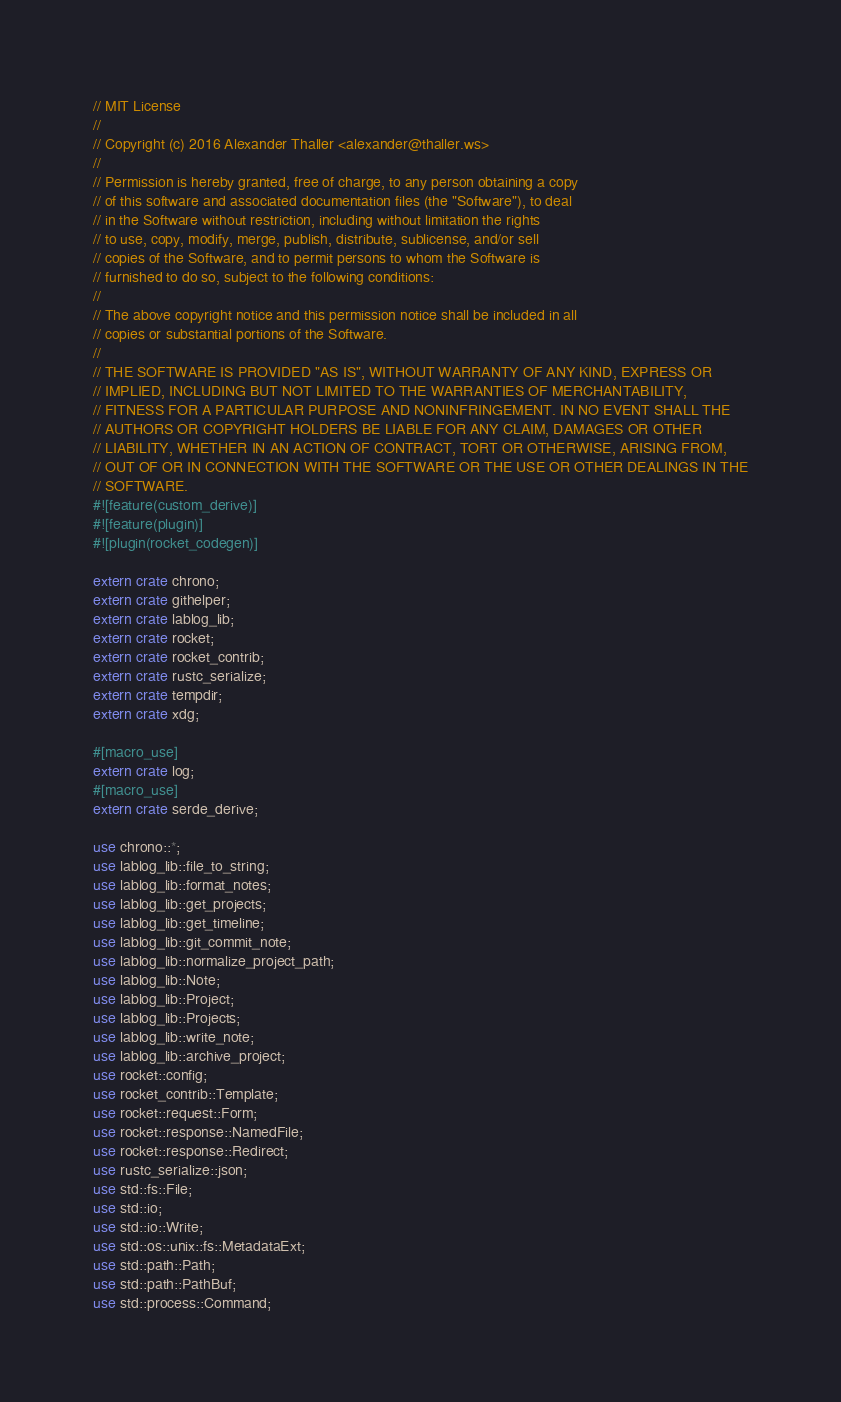Convert code to text. <code><loc_0><loc_0><loc_500><loc_500><_Rust_>// MIT License
//
// Copyright (c) 2016 Alexander Thaller <alexander@thaller.ws>
//
// Permission is hereby granted, free of charge, to any person obtaining a copy
// of this software and associated documentation files (the "Software"), to deal
// in the Software without restriction, including without limitation the rights
// to use, copy, modify, merge, publish, distribute, sublicense, and/or sell
// copies of the Software, and to permit persons to whom the Software is
// furnished to do so, subject to the following conditions:
//
// The above copyright notice and this permission notice shall be included in all
// copies or substantial portions of the Software.
//
// THE SOFTWARE IS PROVIDED "AS IS", WITHOUT WARRANTY OF ANY KIND, EXPRESS OR
// IMPLIED, INCLUDING BUT NOT LIMITED TO THE WARRANTIES OF MERCHANTABILITY,
// FITNESS FOR A PARTICULAR PURPOSE AND NONINFRINGEMENT. IN NO EVENT SHALL THE
// AUTHORS OR COPYRIGHT HOLDERS BE LIABLE FOR ANY CLAIM, DAMAGES OR OTHER
// LIABILITY, WHETHER IN AN ACTION OF CONTRACT, TORT OR OTHERWISE, ARISING FROM,
// OUT OF OR IN CONNECTION WITH THE SOFTWARE OR THE USE OR OTHER DEALINGS IN THE
// SOFTWARE.
#![feature(custom_derive)]
#![feature(plugin)]
#![plugin(rocket_codegen)]

extern crate chrono;
extern crate githelper;
extern crate lablog_lib;
extern crate rocket;
extern crate rocket_contrib;
extern crate rustc_serialize;
extern crate tempdir;
extern crate xdg;

#[macro_use]
extern crate log;
#[macro_use]
extern crate serde_derive;

use chrono::*;
use lablog_lib::file_to_string;
use lablog_lib::format_notes;
use lablog_lib::get_projects;
use lablog_lib::get_timeline;
use lablog_lib::git_commit_note;
use lablog_lib::normalize_project_path;
use lablog_lib::Note;
use lablog_lib::Project;
use lablog_lib::Projects;
use lablog_lib::write_note;
use lablog_lib::archive_project;
use rocket::config;
use rocket_contrib::Template;
use rocket::request::Form;
use rocket::response::NamedFile;
use rocket::response::Redirect;
use rustc_serialize::json;
use std::fs::File;
use std::io;
use std::io::Write;
use std::os::unix::fs::MetadataExt;
use std::path::Path;
use std::path::PathBuf;
use std::process::Command;</code> 